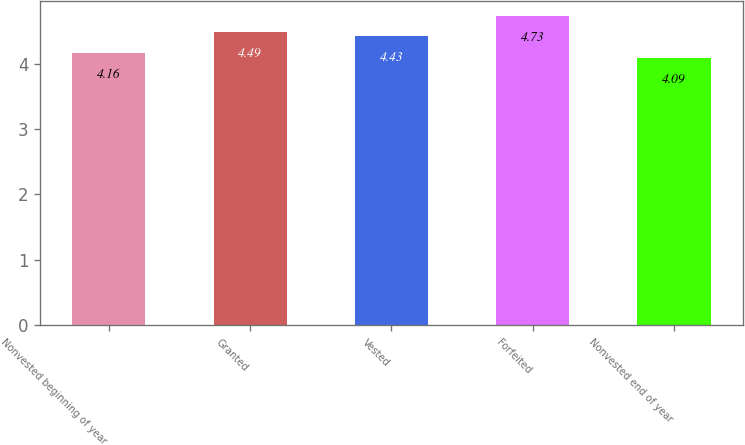<chart> <loc_0><loc_0><loc_500><loc_500><bar_chart><fcel>Nonvested beginning of year<fcel>Granted<fcel>Vested<fcel>Forfeited<fcel>Nonvested end of year<nl><fcel>4.16<fcel>4.49<fcel>4.43<fcel>4.73<fcel>4.09<nl></chart> 